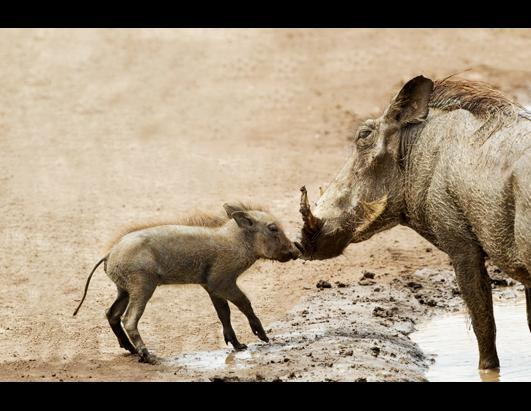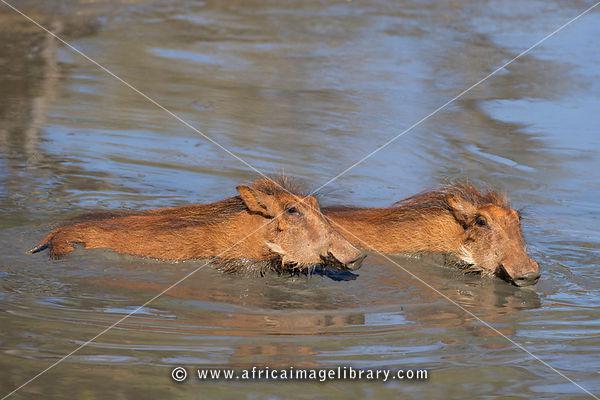The first image is the image on the left, the second image is the image on the right. Evaluate the accuracy of this statement regarding the images: "At least one warthog is near water.". Is it true? Answer yes or no. Yes. The first image is the image on the left, the second image is the image on the right. Considering the images on both sides, is "The image on the left contains no more than two wart hogs." valid? Answer yes or no. Yes. 